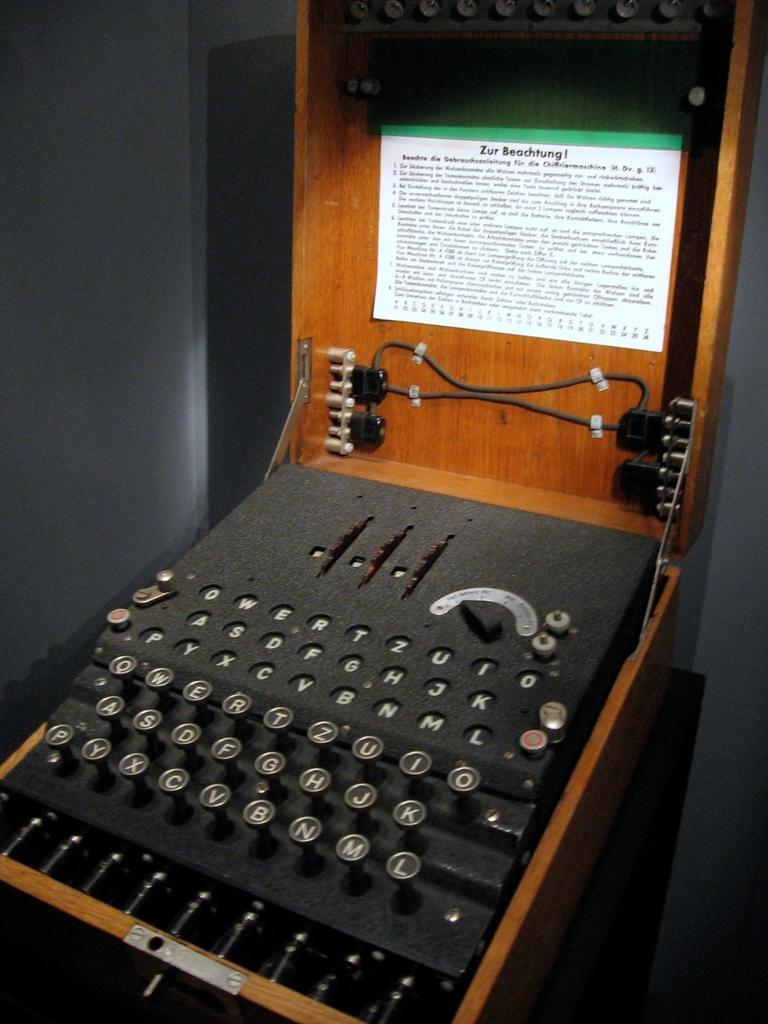How would you summarize this image in a sentence or two? In the center of the image a typewriting machine is there. In the background of the image wall is there. 